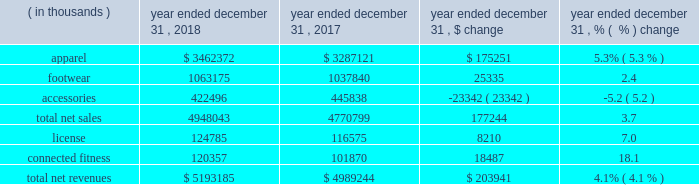Consolidated results of operations year ended december 31 , 2018 compared to year ended december 31 , 2017 net revenues increased $ 203.9 million , or 4.1% ( 4.1 % ) , to $ 5193.2 million in 2018 from $ 4989.2 million in 2017 .
Net revenues by product category are summarized below: .
The increase in net sales was driven primarily by : 2022 apparel unit sales growth driven by the train category ; and 2022 footwear unit sales growth , led by the run category .
The increase was partially offset by unit sales decline in accessories .
License revenues increased $ 8.2 million , or 7.0% ( 7.0 % ) , to $ 124.8 million in 2018 from $ 116.6 million in 2017 .
Connected fitness revenue increased $ 18.5 million , or 18.1% ( 18.1 % ) , to $ 120.4 million in 2018 from $ 101.9 million in 2017 primarily driven by increased subscribers on our fitness applications .
Gross profit increased $ 89.1 million to $ 2340.5 million in 2018 from $ 2251.4 million in 2017 .
Gross profit as a percentage of net revenues , or gross margin , was unchanged at 45.1% ( 45.1 % ) in 2018 compared to 2017 .
Gross profit percentage was favorably impacted by lower promotional activity , improvements in product cost , lower air freight , higher proportion of international and connected fitness revenue and changes in foreign currency ; these favorable impacts were offset by channel mix including higher sales to our off-price channel and restructuring related charges .
With the exception of improvements in product input costs and air freight improvements , we do not expect these trends to have a material impact on the full year 2019 .
Selling , general and administrative expenses increased $ 82.8 million to $ 2182.3 million in 2018 from $ 2099.5 million in 2017 .
As a percentage of net revenues , selling , general and administrative expenses decreased slightly to 42.0% ( 42.0 % ) in 2018 from 42.1% ( 42.1 % ) in 2017 .
Selling , general and administrative expense was impacted by the following : 2022 marketing costs decreased $ 21.3 million to $ 543.8 million in 2018 from $ 565.1 million in 2017 .
This decrease was primarily due to restructuring efforts , resulting in lower compensation and contractual sports marketing .
This decrease was partially offset by higher costs in connection with brand marketing campaigns and increased marketing investments with the growth of our international business .
As a percentage of net revenues , marketing costs decreased to 10.5% ( 10.5 % ) in 2018 from 11.3% ( 11.3 % ) in 2017 .
2022 other costs increased $ 104.1 million to $ 1638.5 million in 2018 from $ 1534.4 million in 2017 .
This increase was primarily due to higher incentive compensation expense and higher costs incurred for the continued expansion of our direct to consumer distribution channel and international business .
As a percentage of net revenues , other costs increased to 31.6% ( 31.6 % ) in 2018 from 30.8% ( 30.8 % ) in 2017 .
Restructuring and impairment charges increased $ 59.1 million to $ 183.1 million from $ 124.0 million in 2017 .
Refer to the restructuring plans section above for a summary of charges .
Income ( loss ) from operations decreased $ 52.8 million , or 189.9% ( 189.9 % ) , to a loss of $ 25.0 million in 2018 from income of $ 27.8 million in 2017 .
As a percentage of net revenues , income from operations decreased to a loss of 0.4% ( 0.4 % ) in 2018 from income of 0.5% ( 0.5 % ) in 2017 .
Income from operations for the year ended december 31 , 2018 was negatively impacted by $ 203.9 million of restructuring , impairment and related charges in connection with the 2018 restructuring plan .
Income from operations for the year ended december 31 , 2017 was negatively impacted by $ 129.1 million of restructuring , impairment and related charges in connection with the 2017 restructuring plan .
Interest expense , net decreased $ 0.9 million to $ 33.6 million in 2018 from $ 34.5 million in 2017. .
What portion of the net revenue is generated by footwear segment in 2018? 
Computations: (1063175 / 5193185)
Answer: 0.20473. 